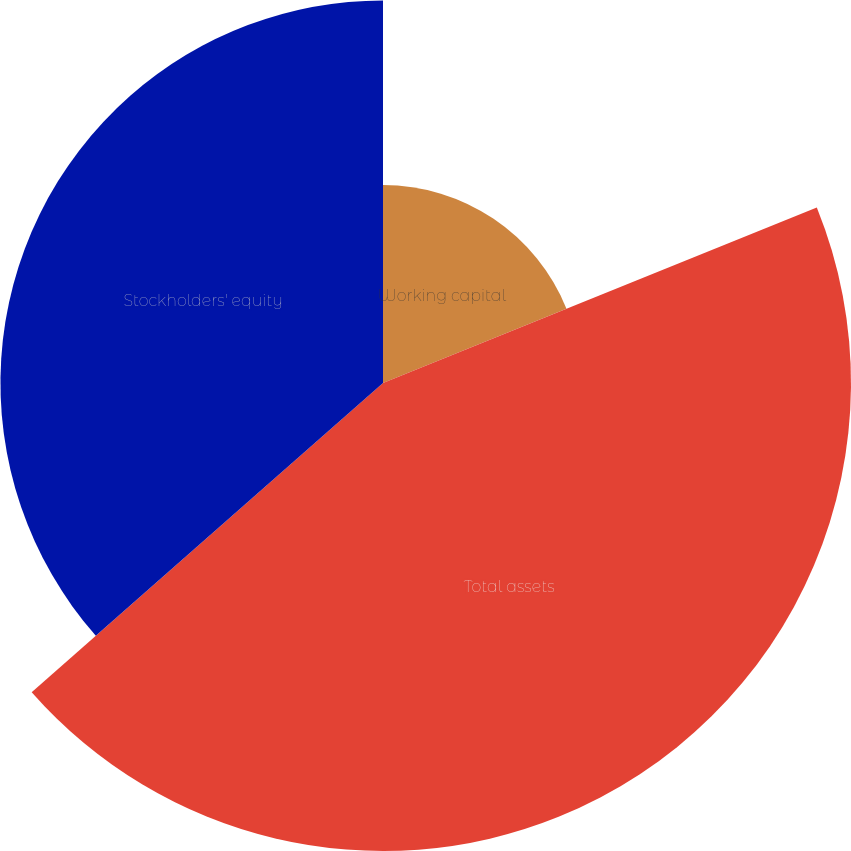Convert chart. <chart><loc_0><loc_0><loc_500><loc_500><pie_chart><fcel>Working capital<fcel>Total assets<fcel>Stockholders' equity<nl><fcel>18.88%<fcel>44.64%<fcel>36.49%<nl></chart> 